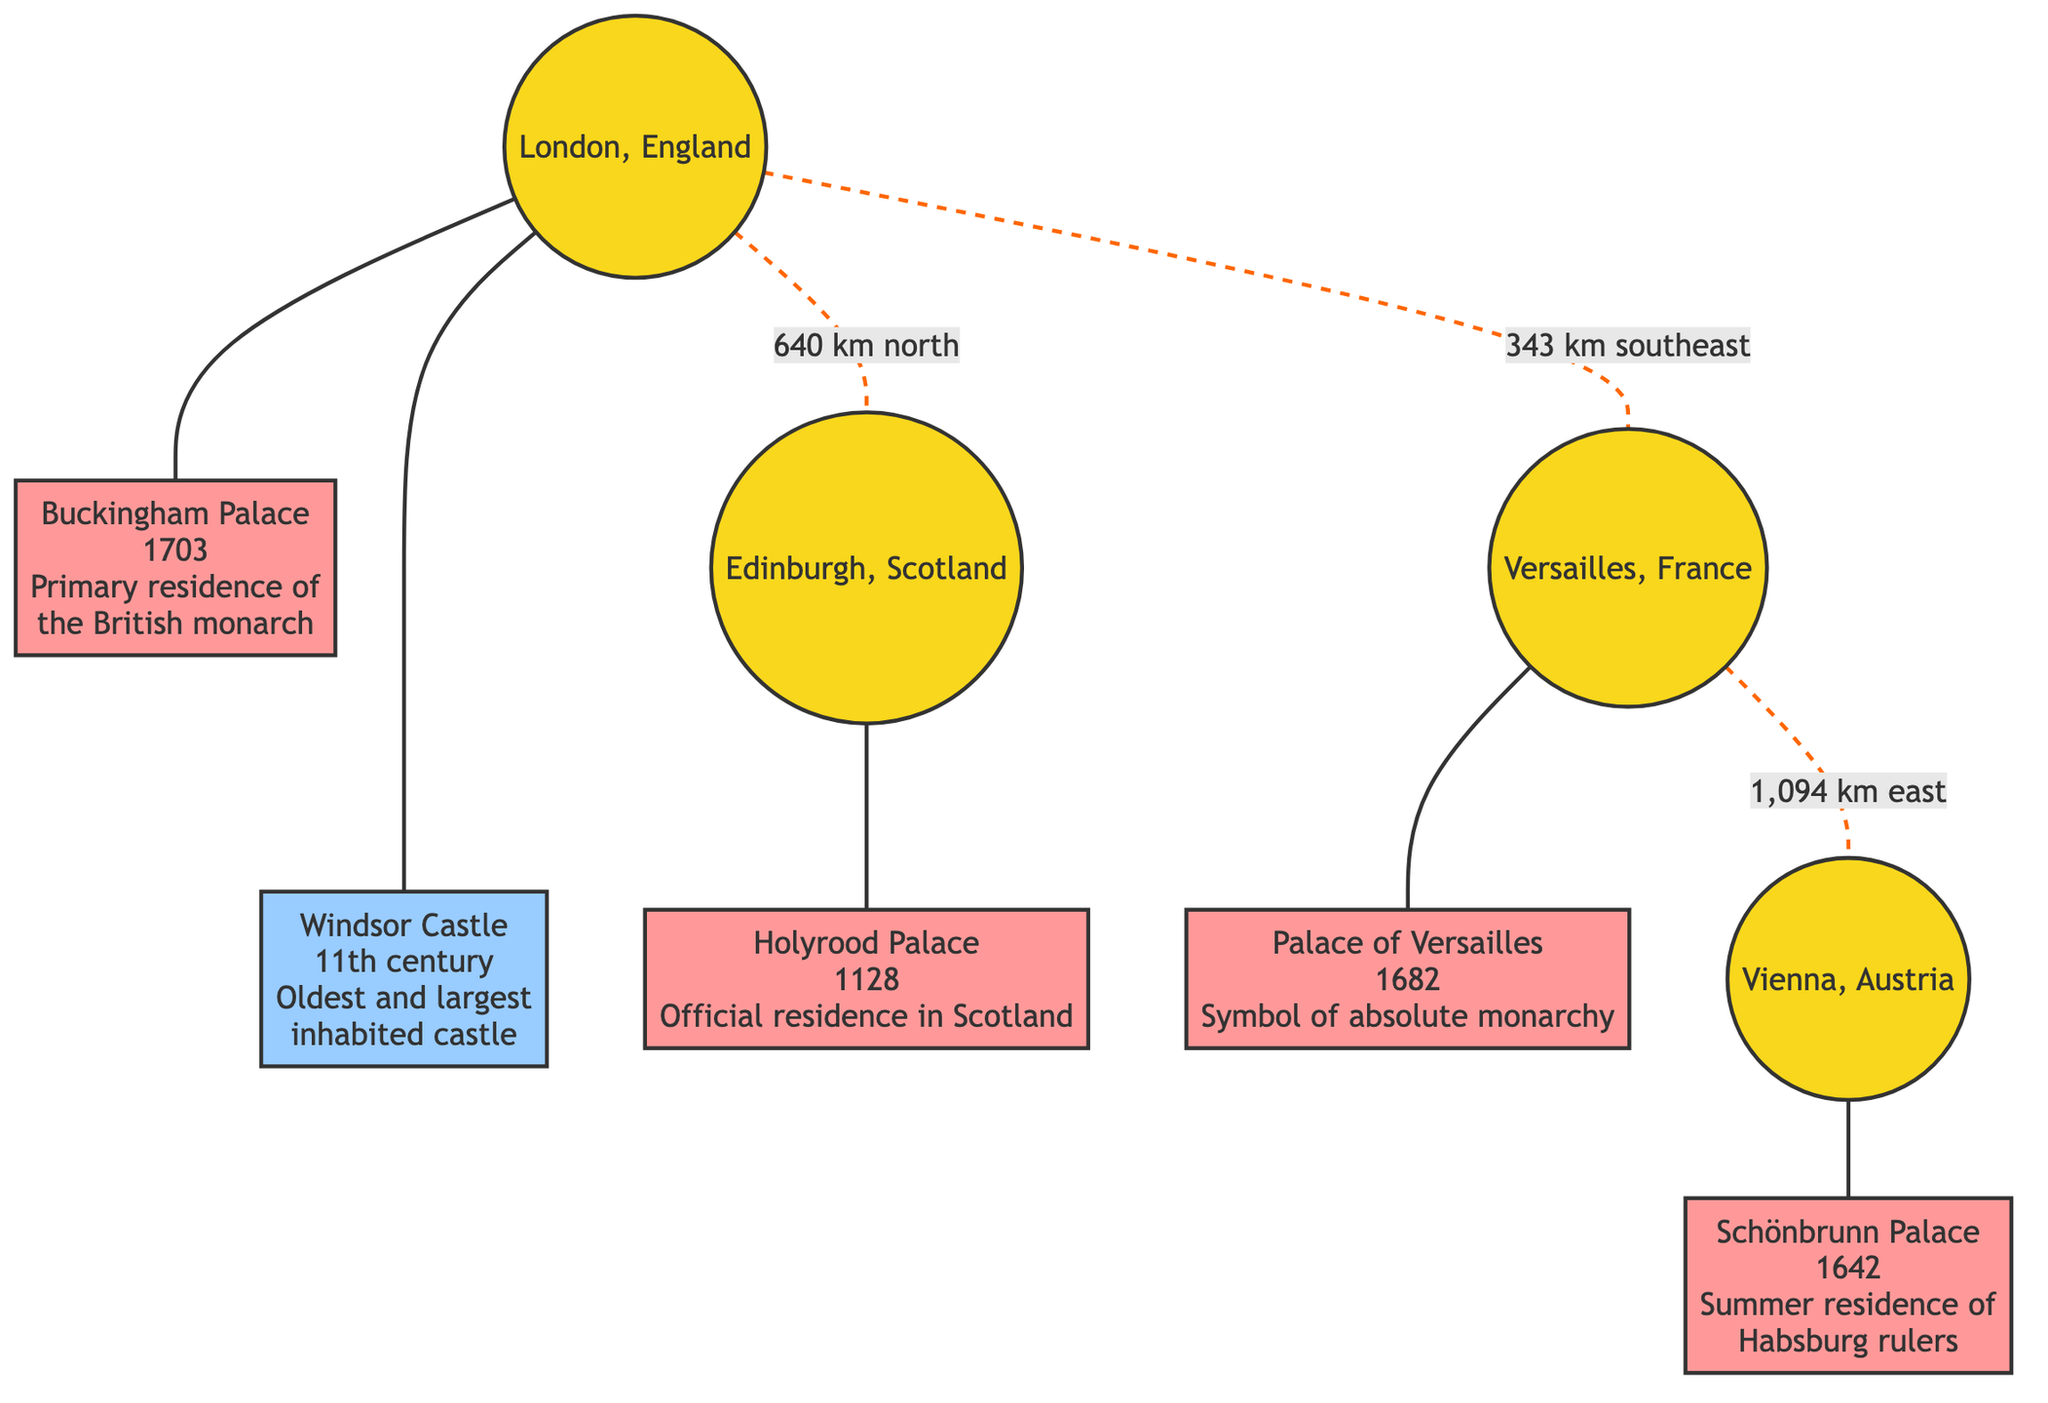What is the primary residence of the British monarch? According to the diagram, Buckingham Palace is identified as the primary residence of the British monarch.
Answer: Buckingham Palace What century was Windsor Castle established in? The diagram states that Windsor Castle dates back to the 11th century, making it the oldest and largest inhabited castle.
Answer: 11th century What city is Holyrood Palace located in? The diagram connects Holyrood Palace to Edinburgh, indicating that it is the official residence in Scotland.
Answer: Edinburgh How far is London from Versailles? The diagram shows a distance of 343 km southeast from London to Versailles.
Answer: 343 km southeast What is the symbol of absolute monarchy as depicted in the diagram? The diagram indicates that the Palace of Versailles is labeled as a symbol of absolute monarchy, highlighting its historical significance.
Answer: Palace of Versailles Which palace was a summer residence of Habsburg rulers? Schönbrunn Palace is defined in the diagram as the summer residence of Habsburg rulers, indicating its significance.
Answer: Schönbrunn Palace Which two cities are connected by a dashed line and what does it represent? The dashed line connects London and Edinburgh, indicating a distance of 640 km north, which signifies the geographical relationship between the two locations.
Answer: 640 km north What is the time span between the establishment of the Palace of Versailles and Schönbrunn Palace? The diagram shows the Palace of Versailles established in 1682 and Schönbrunn Palace established in 1642. Subtracting these dates provides a time span of 40 years between their founding.
Answer: 40 years How many royal residences are mentioned in the diagram? Counting the nodes for the palace and castle categories, there are five royal residences including Buckingham Palace, Windsor Castle, Holyrood Palace, Palace of Versailles, and Schönbrunn Palace.
Answer: Five 